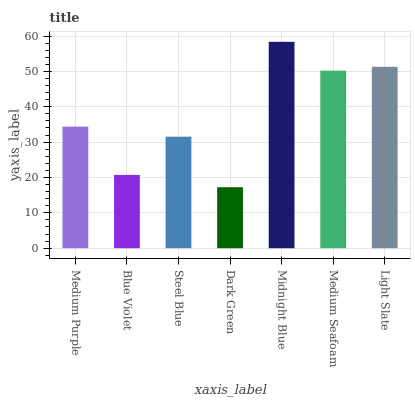Is Dark Green the minimum?
Answer yes or no. Yes. Is Midnight Blue the maximum?
Answer yes or no. Yes. Is Blue Violet the minimum?
Answer yes or no. No. Is Blue Violet the maximum?
Answer yes or no. No. Is Medium Purple greater than Blue Violet?
Answer yes or no. Yes. Is Blue Violet less than Medium Purple?
Answer yes or no. Yes. Is Blue Violet greater than Medium Purple?
Answer yes or no. No. Is Medium Purple less than Blue Violet?
Answer yes or no. No. Is Medium Purple the high median?
Answer yes or no. Yes. Is Medium Purple the low median?
Answer yes or no. Yes. Is Midnight Blue the high median?
Answer yes or no. No. Is Blue Violet the low median?
Answer yes or no. No. 